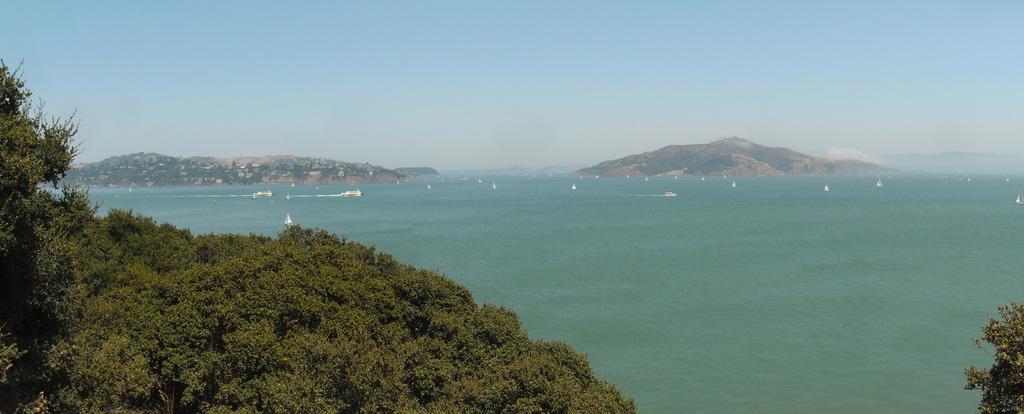Can you describe this image briefly? This picture is clicked outside the city. In the foreground we can see the trees. In the center there are some objects in the water body. In the background we can see the sky, hills and some other objects. 